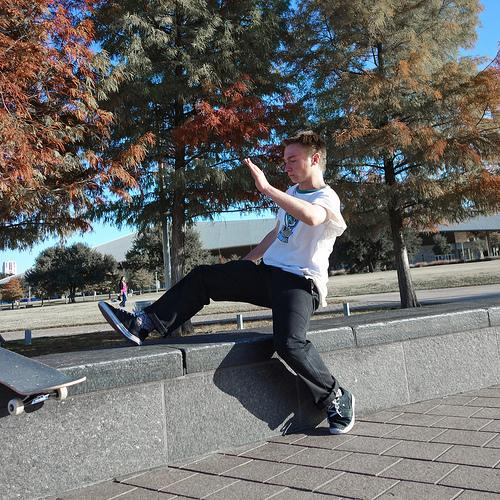What is the focus of this picture, and what makes this subject stand out? The focus of the picture is the young man skateboarding, and his stunts and athletic attire, such as black jeans and sneakers, make him stand out. Describe the setting of the image in terms of the visible environment and objects. The setting features an outdoor environment with trees, a short marble wall, people wearing various clothing items, and a skateboard on the wall, creating an active and lively atmosphere. Can you name some objects and their characteristics that can be seen in this picture? A skateboard on the wall, a tall tree with brown and green leaves, black sneakers, a pink shirt, and marble short wall. What is the primary action being performed by the individual in the image? The boy is jumping over a step while skateboarding. Identify the person walking in the background and their clothing colors. A woman is walking in the background wearing a pink top and a black sweater. Count the number of people and trees in the image. There are 4 people and 3 trees in the image. Enumerate the essential elements in the image and describe their relationships to each other. A boy is performing skateboard stunts near a short marble wall, while a woman walks on the sidewalk in the background, and trees with different colored leaves surround the scene. Provide an evaluation of the emotional atmosphere in the image. The image exhibits a sense of excitement and athleticism, as the boy is performing stunts with his skateboard. How many trees are visible in the image, and what are their leaves' colors? There are three trees in the image, with leaves in green, brown, and red shades. Explain the significance of the black and white sneakers in the photograph. The black and white sneakers are worn by the young man performing stunts on a skateboard, highlighting his style and athleticism. Someone is playing a guitar next to the skateboarder. There is no mention of a person playing a guitar or any musical instrument in the provided image information. This instruction makes a false statement with a declarative sentence about the presence of an additional person and an activity that isn't happening in the image. Can you spot the purple umbrella on the bench in the image? There is no mention of a bench or a purple umbrella in any of the given image information. This instruction uses an interrogative sentence to create curiosity about a nonexistent object. A tall, red fire hydrant is visible near the woman walking on the sidewalk. There is no fire hydrant or any object in red mentioned in the image information. This instruction uses a declarative sentence to make a misleading statement by introducing a false object and its location within the image. Can you find the bicycle parked close to the short wall? The given information does not mention any bicycles in the image. This instruction questions the presence of a nonexistent object, trying to mislead the reader by asking them to find something that isn't there. The image clearly displays a cat sitting beside the skateboard. There is no information related to a cat or any animal in the image. This instruction uses a declarative sentence to make a false statement about the content of the image, causing confusion. How many blue balloons are floating in the sky above the trees? There is no mention of balloons or the color blue in the given image information. This instruction asks a question about nonexistent objects, attempting to create uncertainty about the content of the image. 